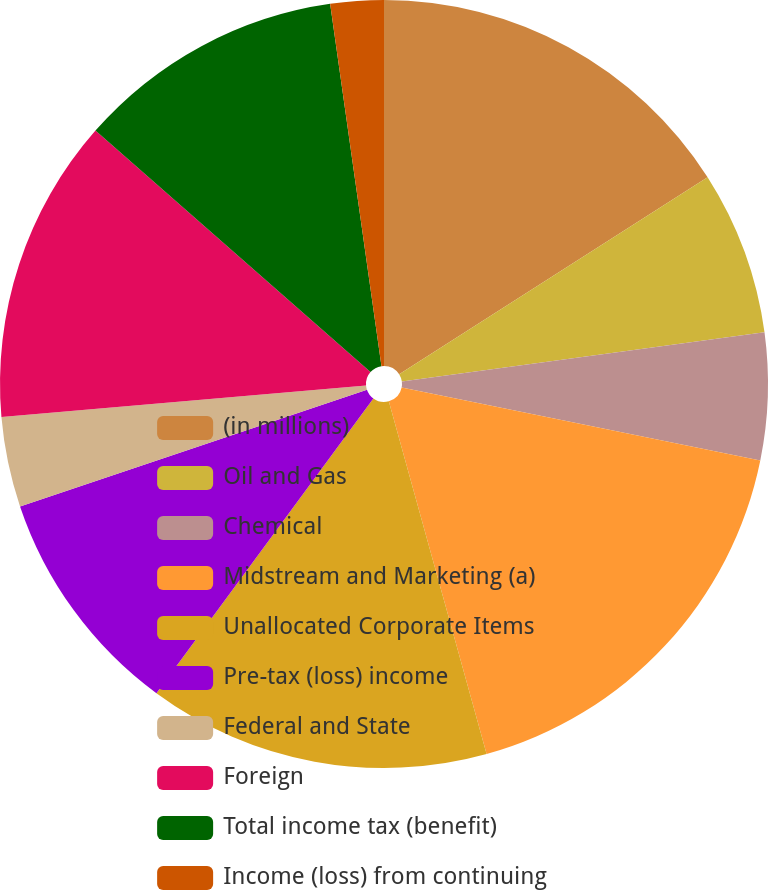Convert chart to OTSL. <chart><loc_0><loc_0><loc_500><loc_500><pie_chart><fcel>(in millions)<fcel>Oil and Gas<fcel>Chemical<fcel>Midstream and Marketing (a)<fcel>Unallocated Corporate Items<fcel>Pre-tax (loss) income<fcel>Federal and State<fcel>Foreign<fcel>Total income tax (benefit)<fcel>Income (loss) from continuing<nl><fcel>15.95%<fcel>6.9%<fcel>5.34%<fcel>17.5%<fcel>14.4%<fcel>9.74%<fcel>3.79%<fcel>12.84%<fcel>11.29%<fcel>2.24%<nl></chart> 